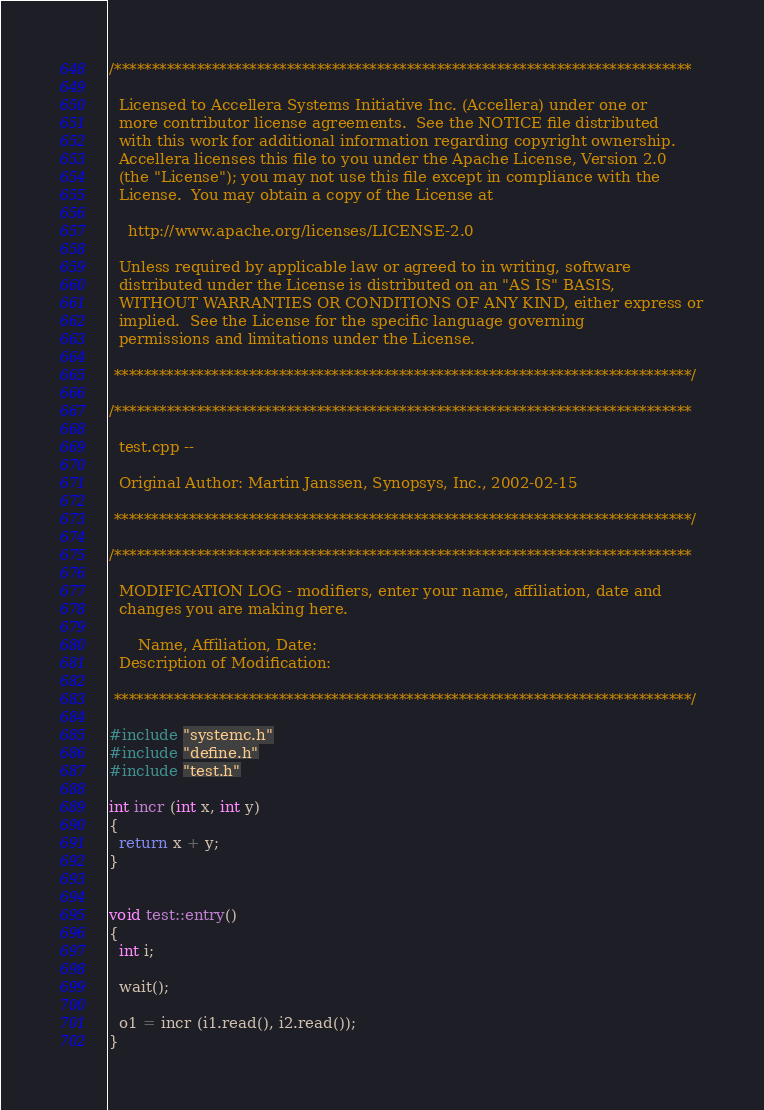<code> <loc_0><loc_0><loc_500><loc_500><_C++_>/*****************************************************************************

  Licensed to Accellera Systems Initiative Inc. (Accellera) under one or
  more contributor license agreements.  See the NOTICE file distributed
  with this work for additional information regarding copyright ownership.
  Accellera licenses this file to you under the Apache License, Version 2.0
  (the "License"); you may not use this file except in compliance with the
  License.  You may obtain a copy of the License at

    http://www.apache.org/licenses/LICENSE-2.0

  Unless required by applicable law or agreed to in writing, software
  distributed under the License is distributed on an "AS IS" BASIS,
  WITHOUT WARRANTIES OR CONDITIONS OF ANY KIND, either express or
  implied.  See the License for the specific language governing
  permissions and limitations under the License.

 *****************************************************************************/

/*****************************************************************************

  test.cpp -- 

  Original Author: Martin Janssen, Synopsys, Inc., 2002-02-15

 *****************************************************************************/

/*****************************************************************************

  MODIFICATION LOG - modifiers, enter your name, affiliation, date and
  changes you are making here.

      Name, Affiliation, Date:
  Description of Modification:

 *****************************************************************************/

#include "systemc.h"
#include "define.h"
#include "test.h"
 
int incr (int x, int y)
{
  return x + y;
}


void test::entry() 
{
  int i;

  wait();

  o1 = incr (i1.read(), i2.read());
}
</code> 